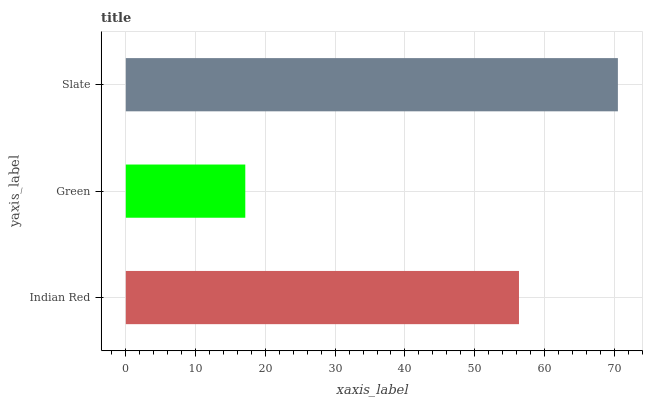Is Green the minimum?
Answer yes or no. Yes. Is Slate the maximum?
Answer yes or no. Yes. Is Slate the minimum?
Answer yes or no. No. Is Green the maximum?
Answer yes or no. No. Is Slate greater than Green?
Answer yes or no. Yes. Is Green less than Slate?
Answer yes or no. Yes. Is Green greater than Slate?
Answer yes or no. No. Is Slate less than Green?
Answer yes or no. No. Is Indian Red the high median?
Answer yes or no. Yes. Is Indian Red the low median?
Answer yes or no. Yes. Is Slate the high median?
Answer yes or no. No. Is Green the low median?
Answer yes or no. No. 